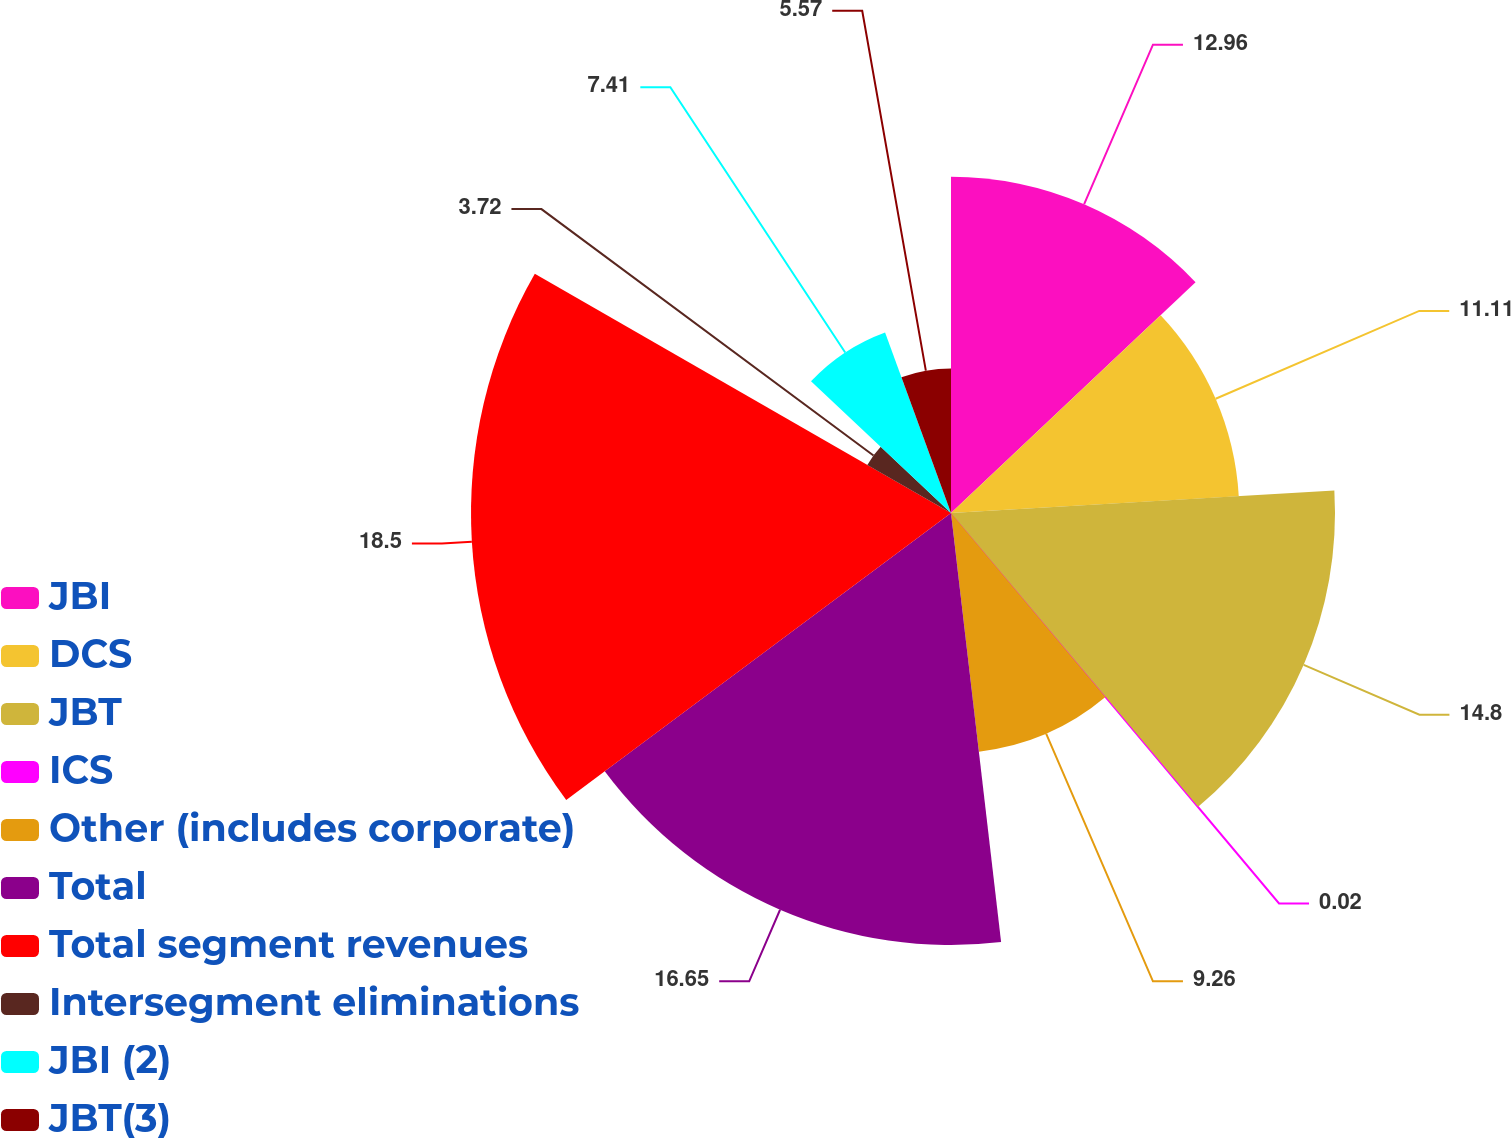Convert chart to OTSL. <chart><loc_0><loc_0><loc_500><loc_500><pie_chart><fcel>JBI<fcel>DCS<fcel>JBT<fcel>ICS<fcel>Other (includes corporate)<fcel>Total<fcel>Total segment revenues<fcel>Intersegment eliminations<fcel>JBI (2)<fcel>JBT(3)<nl><fcel>12.96%<fcel>11.11%<fcel>14.8%<fcel>0.02%<fcel>9.26%<fcel>16.65%<fcel>18.5%<fcel>3.72%<fcel>7.41%<fcel>5.57%<nl></chart> 